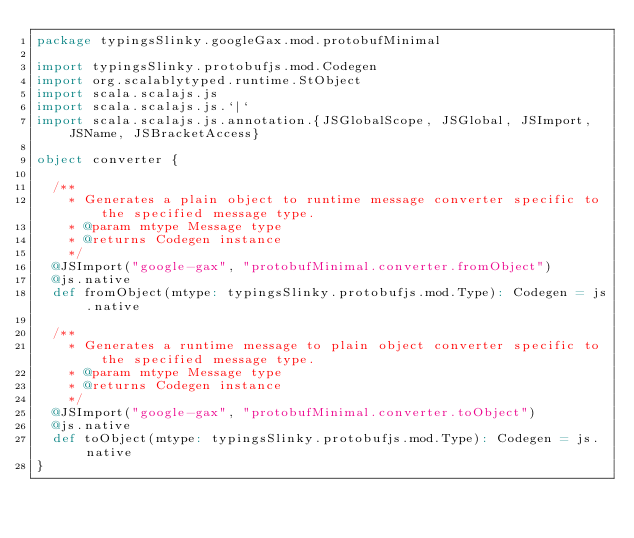<code> <loc_0><loc_0><loc_500><loc_500><_Scala_>package typingsSlinky.googleGax.mod.protobufMinimal

import typingsSlinky.protobufjs.mod.Codegen
import org.scalablytyped.runtime.StObject
import scala.scalajs.js
import scala.scalajs.js.`|`
import scala.scalajs.js.annotation.{JSGlobalScope, JSGlobal, JSImport, JSName, JSBracketAccess}

object converter {
  
  /**
    * Generates a plain object to runtime message converter specific to the specified message type.
    * @param mtype Message type
    * @returns Codegen instance
    */
  @JSImport("google-gax", "protobufMinimal.converter.fromObject")
  @js.native
  def fromObject(mtype: typingsSlinky.protobufjs.mod.Type): Codegen = js.native
  
  /**
    * Generates a runtime message to plain object converter specific to the specified message type.
    * @param mtype Message type
    * @returns Codegen instance
    */
  @JSImport("google-gax", "protobufMinimal.converter.toObject")
  @js.native
  def toObject(mtype: typingsSlinky.protobufjs.mod.Type): Codegen = js.native
}
</code> 